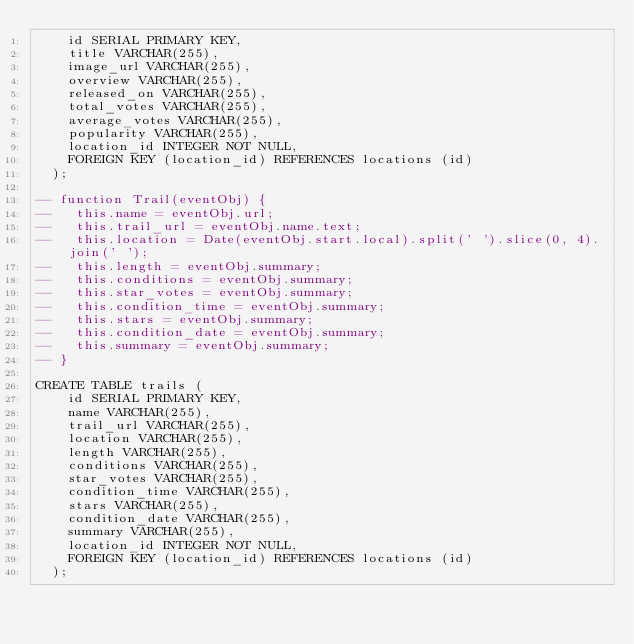Convert code to text. <code><loc_0><loc_0><loc_500><loc_500><_SQL_>    id SERIAL PRIMARY KEY, 
    title VARCHAR(255), 
    image_url VARCHAR(255), 
    overview VARCHAR(255), 
    released_on VARCHAR(255), 
    total_votes VARCHAR(255), 
    average_votes VARCHAR(255), 
    popularity VARCHAR(255), 
    location_id INTEGER NOT NULL,
    FOREIGN KEY (location_id) REFERENCES locations (id)
  );

-- function Trail(eventObj) {
--   this.name = eventObj.url;
--   this.trail_url = eventObj.name.text;
--   this.location = Date(eventObj.start.local).split(' ').slice(0, 4).join(' ');
--   this.length = eventObj.summary;
--   this.conditions = eventObj.summary;
--   this.star_votes = eventObj.summary;
--   this.condition_time = eventObj.summary;
--   this.stars = eventObj.summary;
--   this.condition_date = eventObj.summary;
--   this.summary = eventObj.summary;
-- }

CREATE TABLE trails ( 
    id SERIAL PRIMARY KEY, 
    name VARCHAR(255), 
    trail_url VARCHAR(255), 
    location VARCHAR(255), 
    length VARCHAR(255), 
    conditions VARCHAR(255), 
    star_votes VARCHAR(255), 
    condition_time VARCHAR(255), 
    stars VARCHAR(255), 
    condition_date VARCHAR(255), 
    summary VARCHAR(255), 
    location_id INTEGER NOT NULL,
    FOREIGN KEY (location_id) REFERENCES locations (id)
  );
</code> 